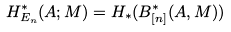<formula> <loc_0><loc_0><loc_500><loc_500>H ^ { * } _ { E _ { n } } ( A ; M ) = H _ { * } ( B _ { [ n ] } ^ { * } ( A , M ) )</formula> 